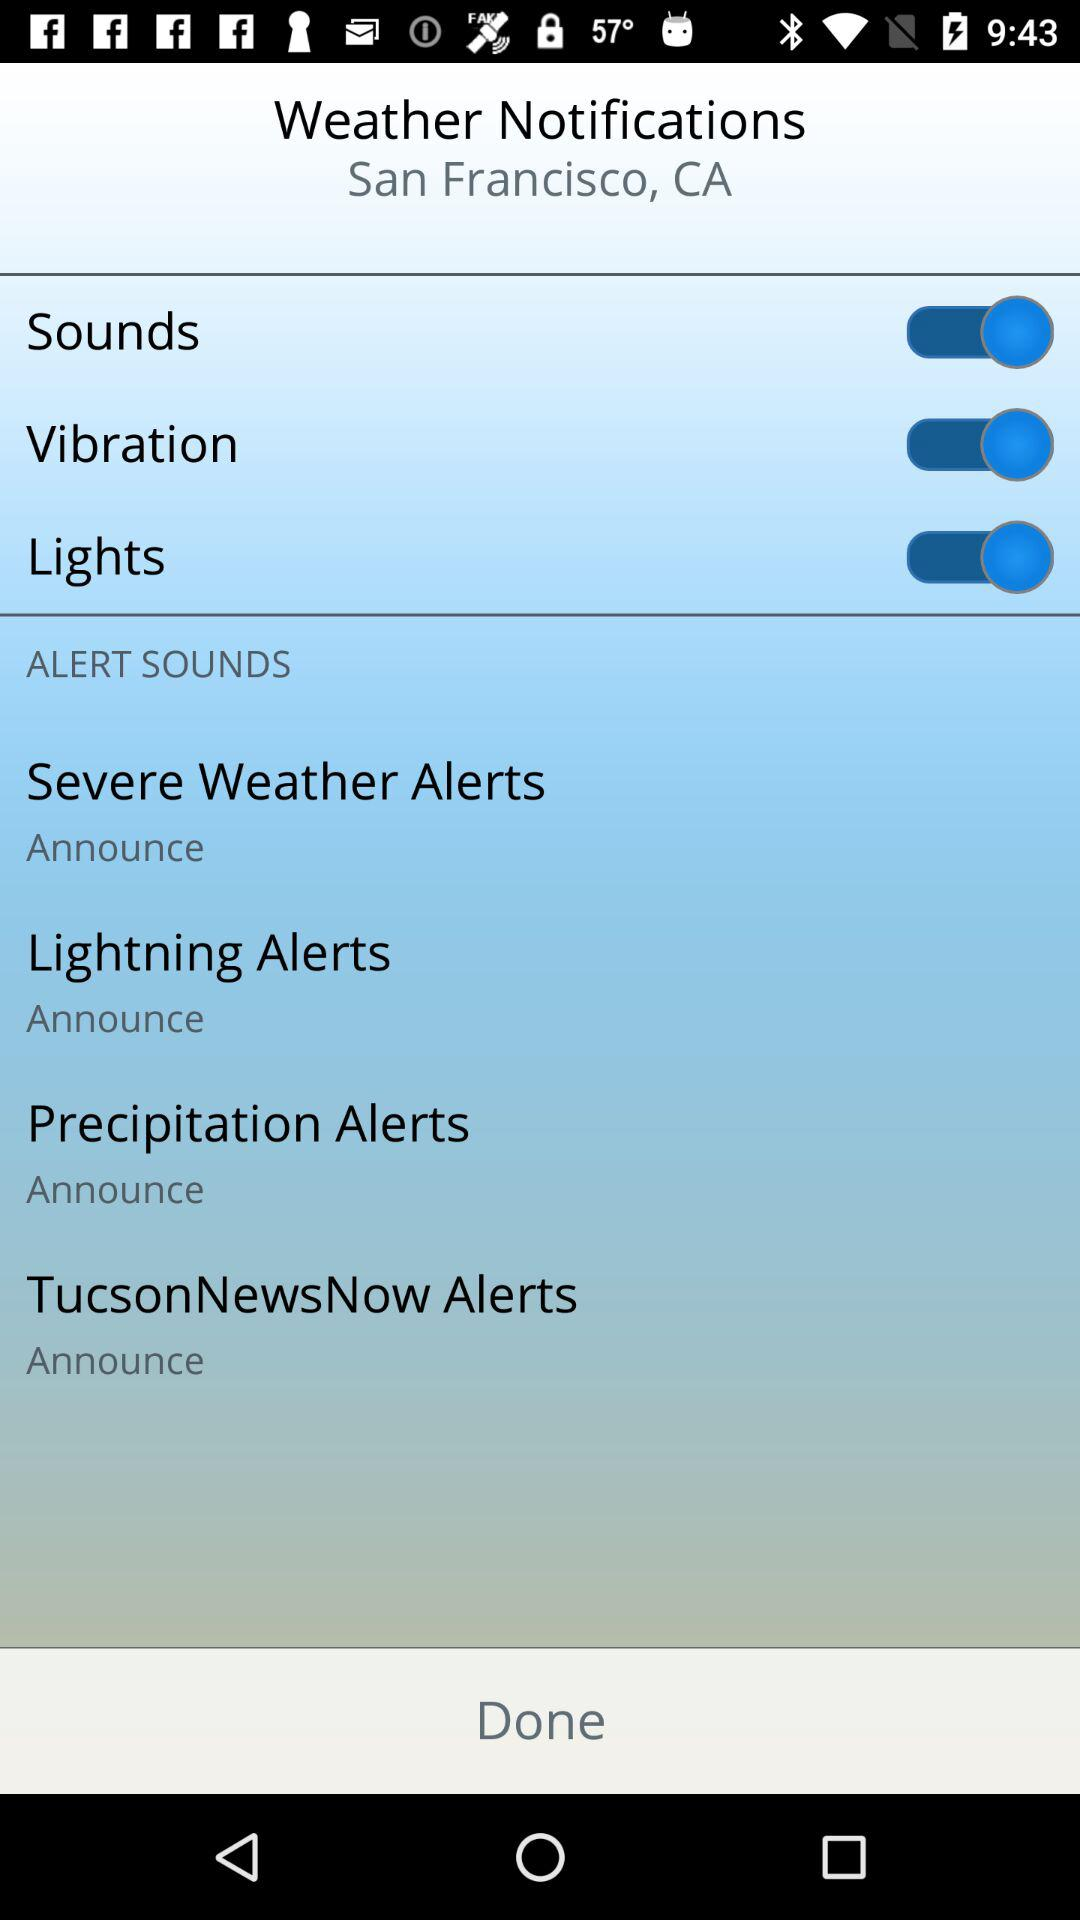What is the status of the "Sounds" notification setting? The status of the "Sounds" notification setting is "on". 